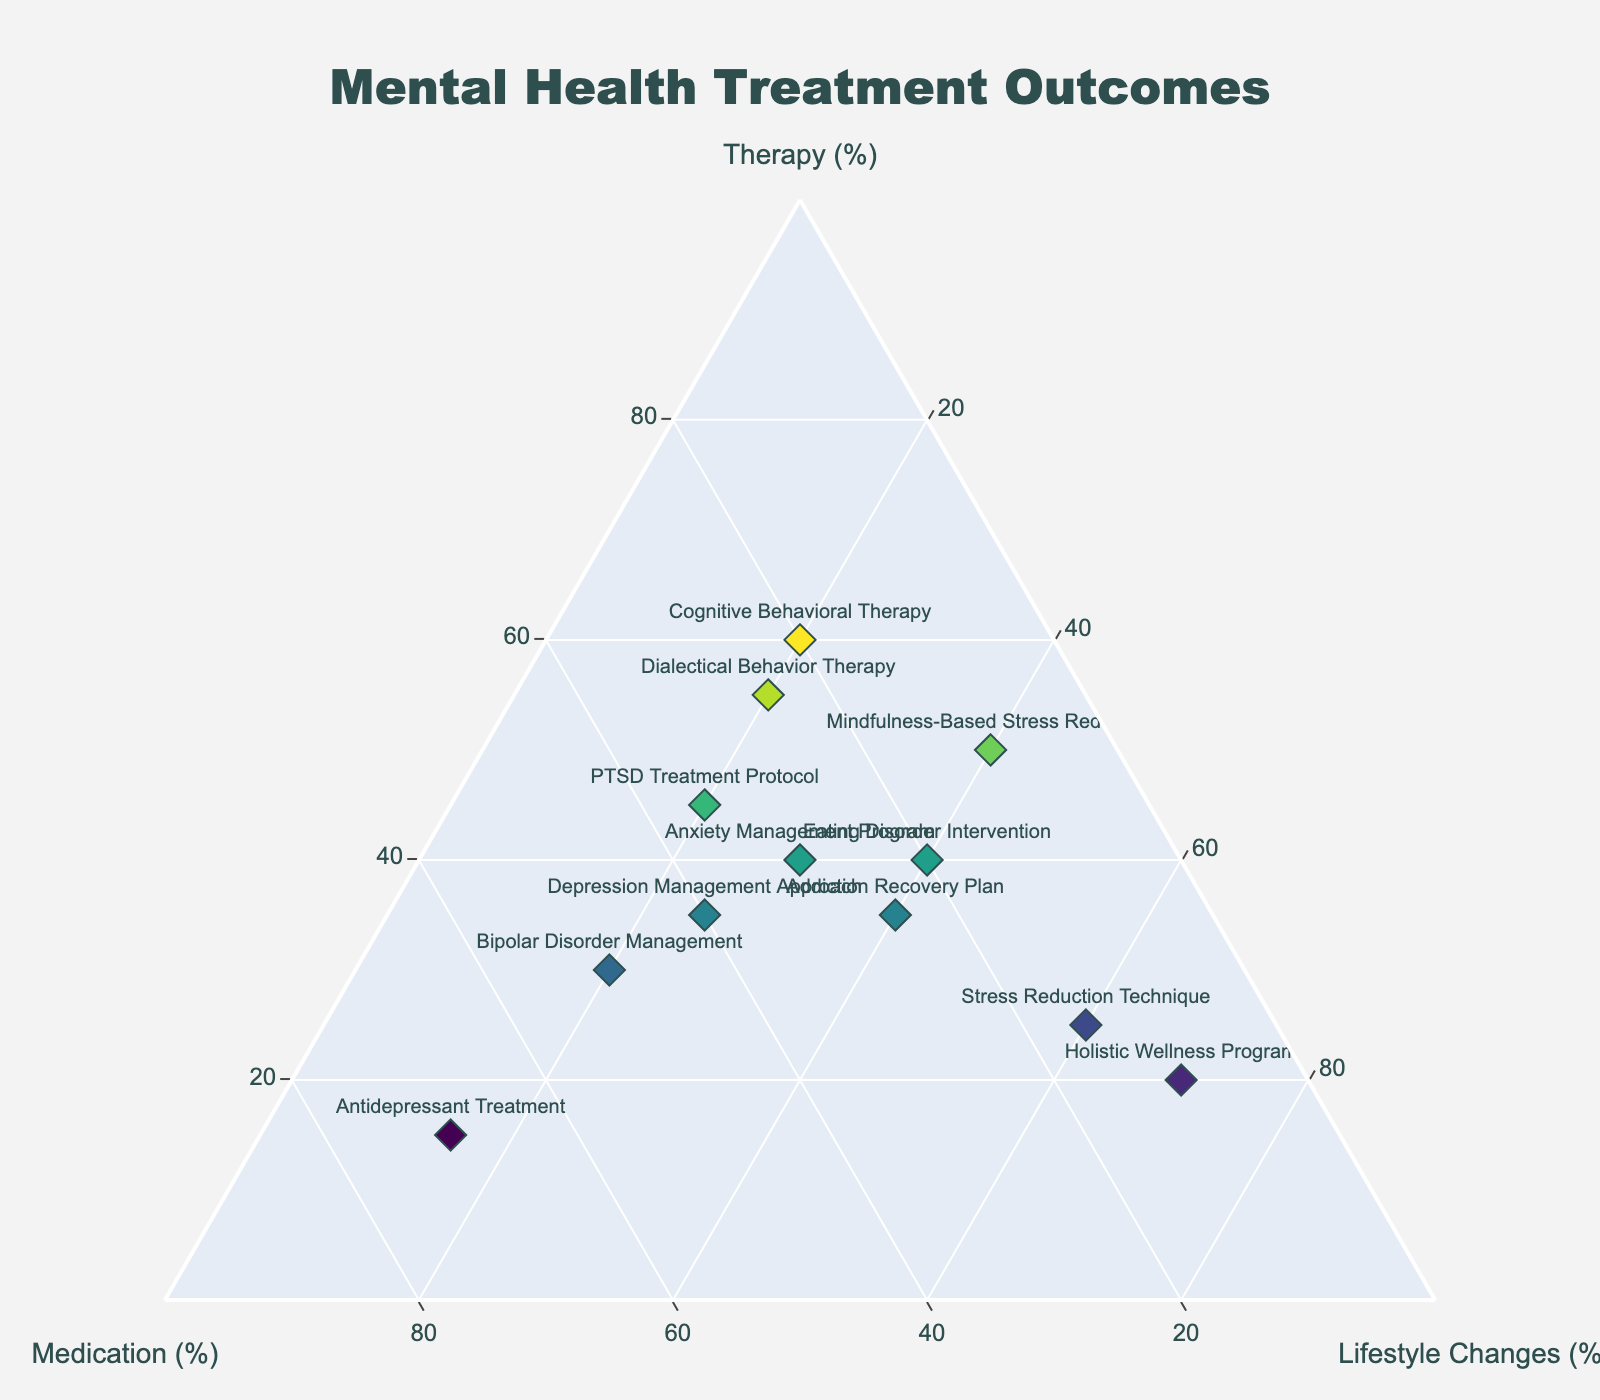What is the title of the figure? The title of the figure is typically located at the top and provides an overview of the data being visualized. In this case, it states "Mental Health Treatment Outcomes".
Answer: Mental Health Treatment Outcomes Which treatment has the highest percentage of therapy? To find this, look at the apex of the ternary plot corresponding to the 'Therapy' axis and find the point closest to that apex. The treatment at that point has the highest percentage of therapy, which is Cognitive Behavioral Therapy with 60%.
Answer: Cognitive Behavioral Therapy How many treatments have a higher percentage of medication than lifestyle changes? Compare the 'Medication' and 'Lifestyle Changes' percentages for each treatment. Count the treatments where the medication percentage is higher than the lifestyle changes. There are four such treatments: Antidepressant Treatment, Bipolar Disorder Management, PTSD Treatment Protocol, and Depression Management Approach.
Answer: 4 Which treatment method shows the most balanced outcome among therapy, medication, and lifestyle changes? A balanced outcome means the data point is closest to the center of the ternary plot where all percentages are nearly equal. The Anxiety Management Program, with 40% therapy, 30% medication, and 30% lifestyle changes, appears most balanced.
Answer: Anxiety Management Program Which treatment has the lowest percentage of therapy? Find the treatment point closest to the axis opposite to the 'Therapy' apex, indicating the lowest percentage of therapy. The Holistic Wellness Program has the lowest therapy percentage at 20%.
Answer: Holistic Wellness Program What is the sum of the therapy percentages for Cognitive Behavioral Therapy, Mindfulness-Based Stress Reduction, and Dialectical Behavior Therapy? Add the percentage of therapy for these three treatments: 60% (Cognitive Behavioral Therapy) + 50% (Mindfulness-Based Stress Reduction) + 55% (Dialectical Behavior Therapy) = 165%.
Answer: 165% Compare the percentages of lifestyle changes between the Addiction Recovery Plan and Eating Disorder Intervention. Which one is higher? Look at the 'Lifestyle Changes' percentages for both treatments. The Addiction Recovery Plan has 40%, while the Eating Disorder Intervention also has 40%. Thus, they are equal.
Answer: Equal Which pair of treatments has the closest percentages in medication? Compare the medication percentages for all treatments and find the pair with the smallest difference. Cognitive Behavioral Therapy (20%) and Eating Disorder Intervention (20%) have the closest percentages.
Answer: Cognitive Behavioral Therapy and Eating Disorder Intervention What is the average percentage of lifestyle changes across all treatments? Sum the 'Lifestyle Changes' percentages for all treatments and divide by the number of treatments. (20 + 40 + 20 + 15 + 30 + 40 + 20 + 20 + 40 + 60 + 25 + 70) / 12 = 400 / 12 ≈ 33.33%.
Answer: 33.33% Which color represents the highest therapy percentage? Colorscale, 'Viridis,' is used, where darker shades typically represent higher values. The color for the highest therapy percentage (Cognitive Behavioral Therapy) is the darkest among the shades plotted, corresponding to 60%.
Answer: Darkest shade 